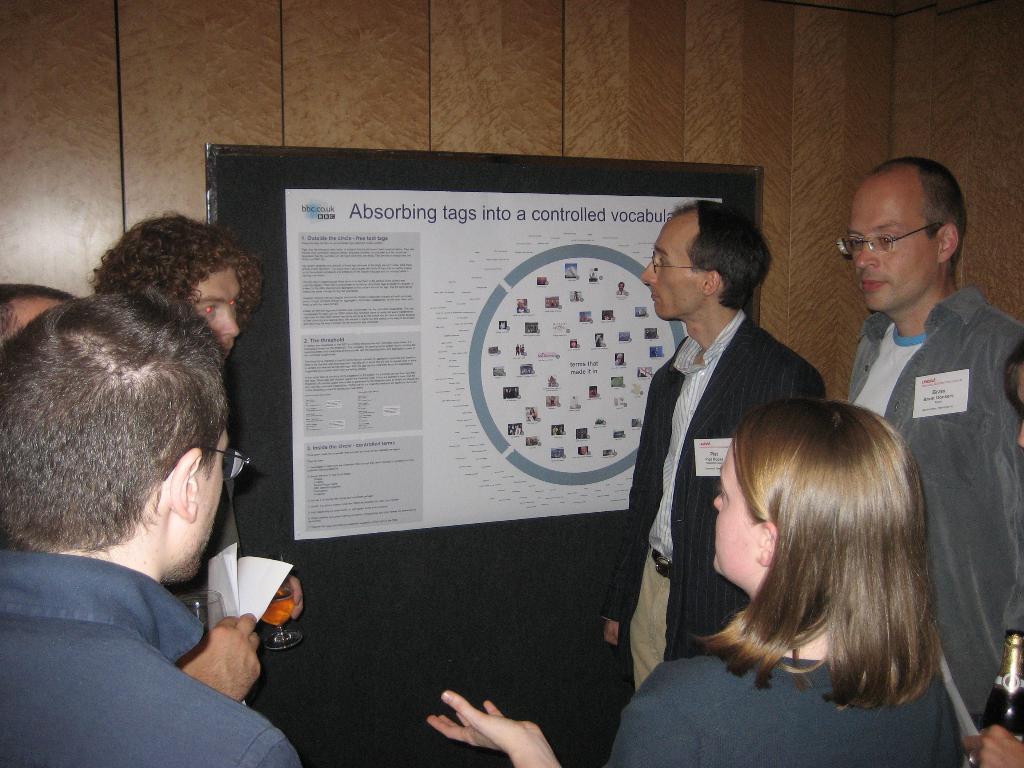Could you give a brief overview of what you see in this image? In this image we can see a few people standing, among them some people are holding the objects, in the background, we can see the wall with a board, on the board we can see a poster with some text and images. 